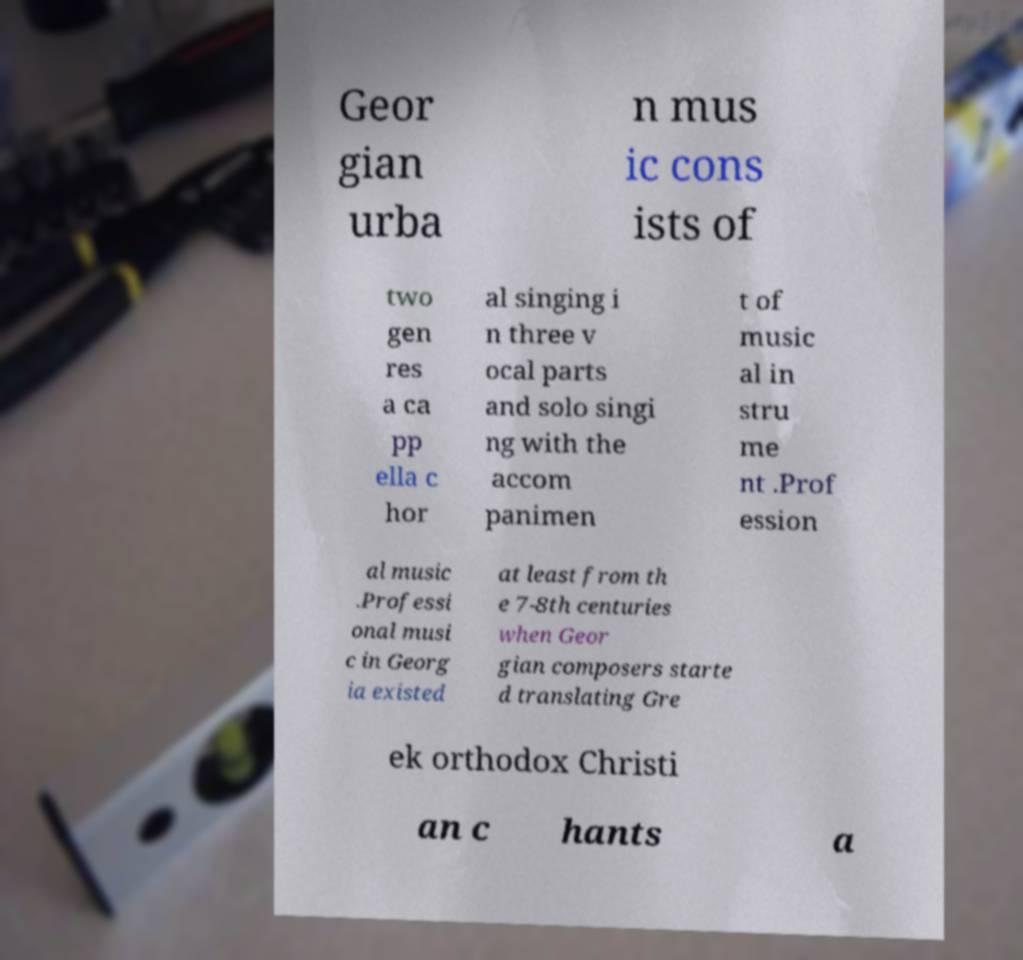What messages or text are displayed in this image? I need them in a readable, typed format. Geor gian urba n mus ic cons ists of two gen res a ca pp ella c hor al singing i n three v ocal parts and solo singi ng with the accom panimen t of music al in stru me nt .Prof ession al music .Professi onal musi c in Georg ia existed at least from th e 7-8th centuries when Geor gian composers starte d translating Gre ek orthodox Christi an c hants a 